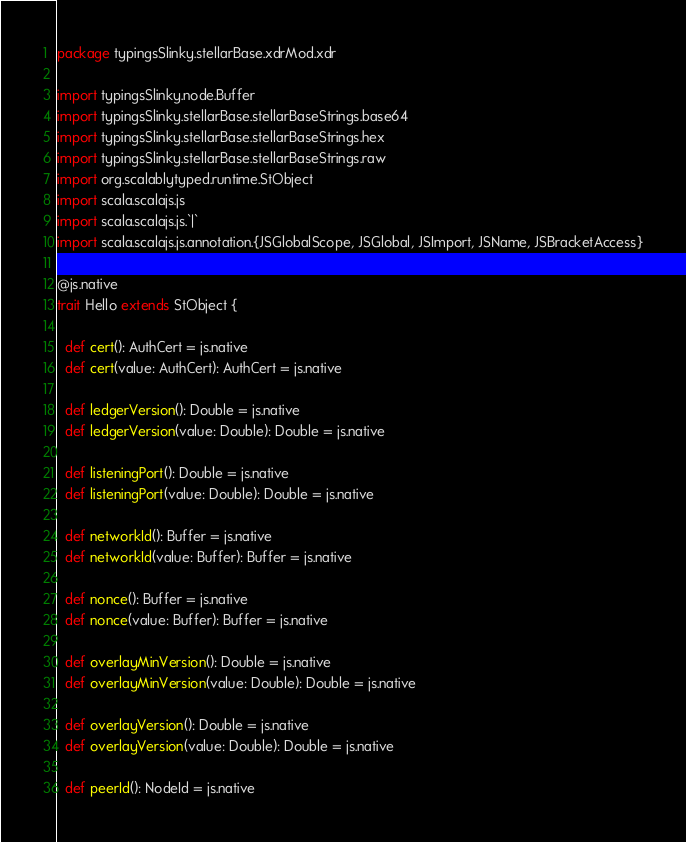<code> <loc_0><loc_0><loc_500><loc_500><_Scala_>package typingsSlinky.stellarBase.xdrMod.xdr

import typingsSlinky.node.Buffer
import typingsSlinky.stellarBase.stellarBaseStrings.base64
import typingsSlinky.stellarBase.stellarBaseStrings.hex
import typingsSlinky.stellarBase.stellarBaseStrings.raw
import org.scalablytyped.runtime.StObject
import scala.scalajs.js
import scala.scalajs.js.`|`
import scala.scalajs.js.annotation.{JSGlobalScope, JSGlobal, JSImport, JSName, JSBracketAccess}

@js.native
trait Hello extends StObject {
  
  def cert(): AuthCert = js.native
  def cert(value: AuthCert): AuthCert = js.native
  
  def ledgerVersion(): Double = js.native
  def ledgerVersion(value: Double): Double = js.native
  
  def listeningPort(): Double = js.native
  def listeningPort(value: Double): Double = js.native
  
  def networkId(): Buffer = js.native
  def networkId(value: Buffer): Buffer = js.native
  
  def nonce(): Buffer = js.native
  def nonce(value: Buffer): Buffer = js.native
  
  def overlayMinVersion(): Double = js.native
  def overlayMinVersion(value: Double): Double = js.native
  
  def overlayVersion(): Double = js.native
  def overlayVersion(value: Double): Double = js.native
  
  def peerId(): NodeId = js.native</code> 